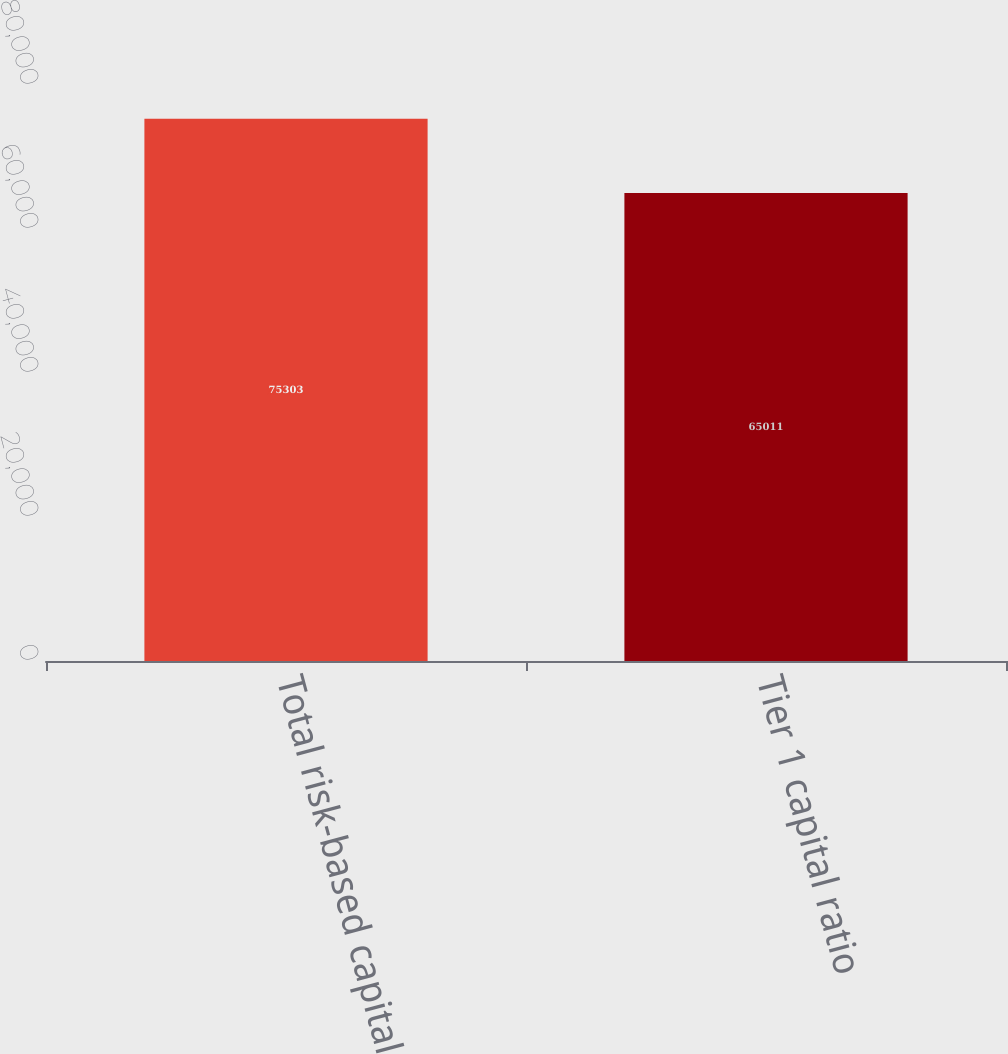Convert chart. <chart><loc_0><loc_0><loc_500><loc_500><bar_chart><fcel>Total risk-based capital ratio<fcel>Tier 1 capital ratio<nl><fcel>75303<fcel>65011<nl></chart> 